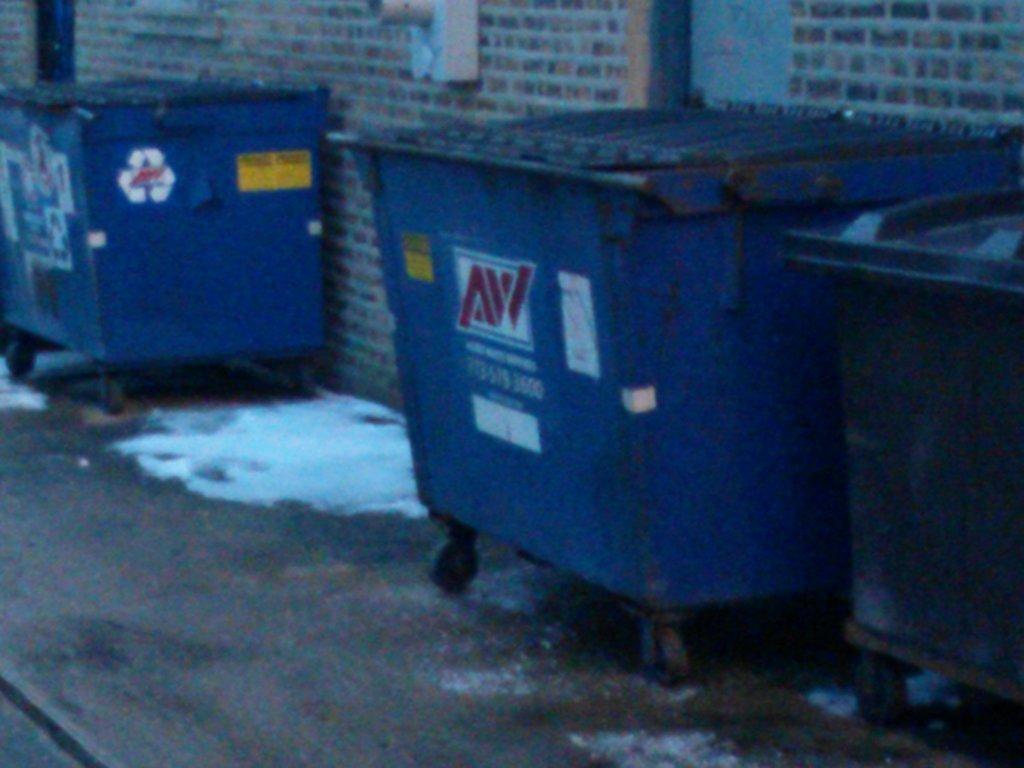Provide a one-sentence caption for the provided image. Dumpsters from the AW company sit in an alley. 